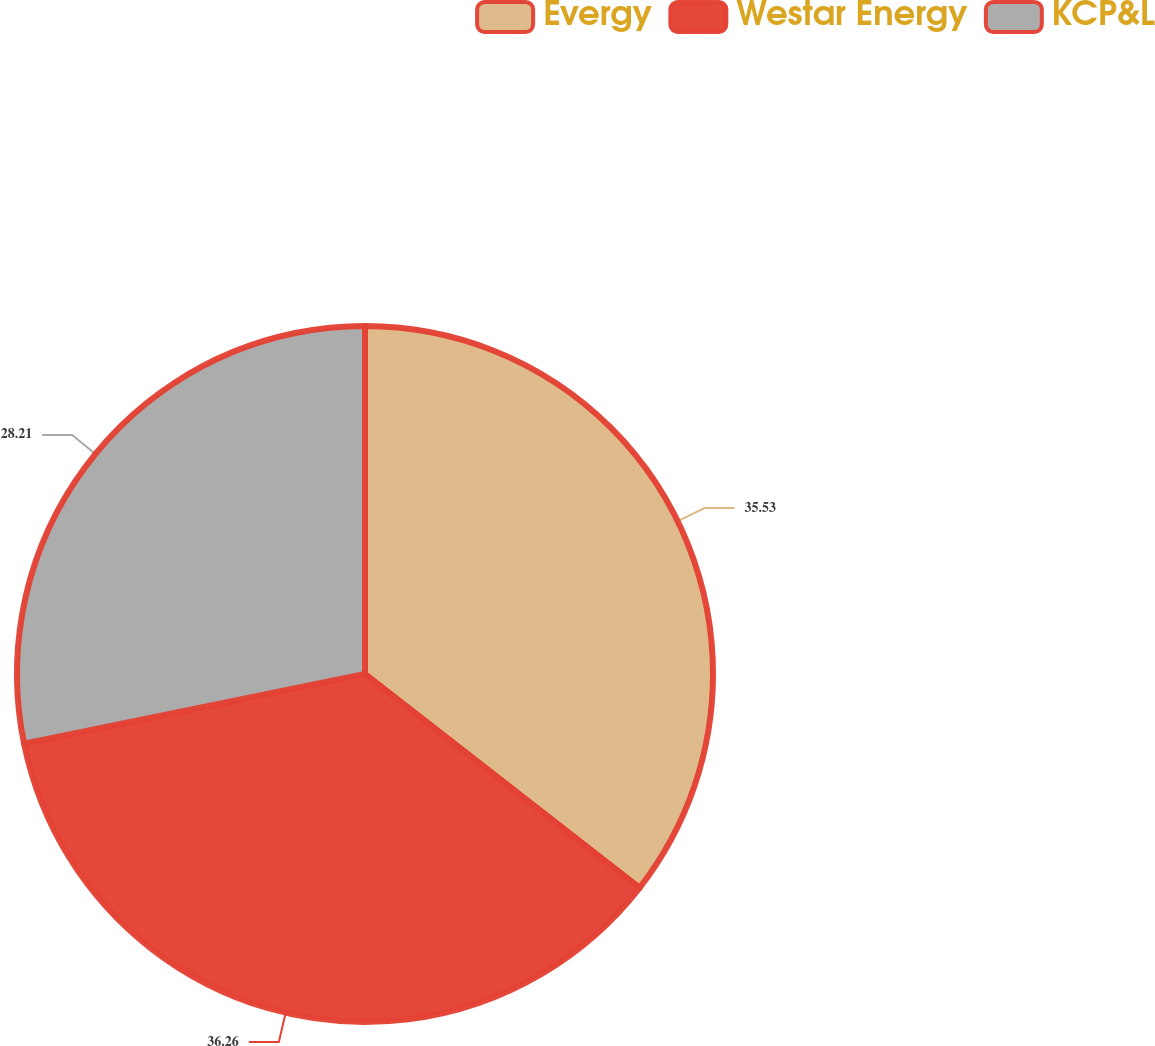<chart> <loc_0><loc_0><loc_500><loc_500><pie_chart><fcel>Evergy<fcel>Westar Energy<fcel>KCP&L<nl><fcel>35.53%<fcel>36.26%<fcel>28.21%<nl></chart> 